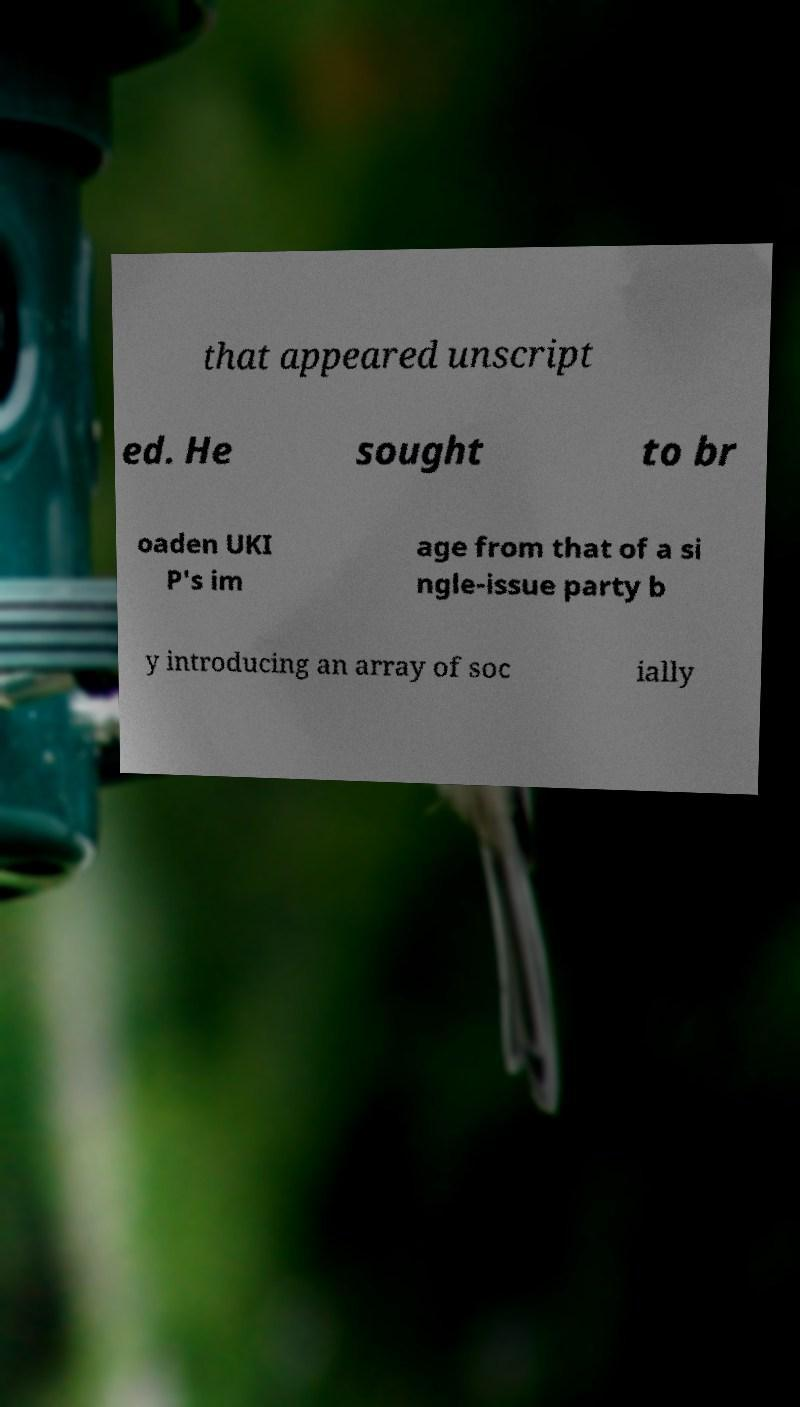For documentation purposes, I need the text within this image transcribed. Could you provide that? that appeared unscript ed. He sought to br oaden UKI P's im age from that of a si ngle-issue party b y introducing an array of soc ially 